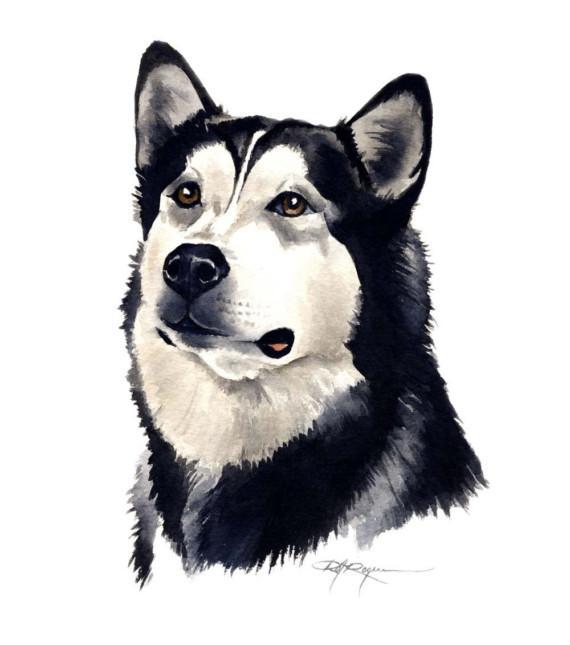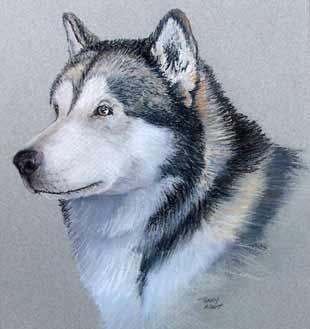The first image is the image on the left, the second image is the image on the right. Assess this claim about the two images: "The right image features a dog with its head and body angled leftward and its tongue hanging out.". Correct or not? Answer yes or no. No. The first image is the image on the left, the second image is the image on the right. Assess this claim about the two images: "In one image the head and paws of an Alaskan Malamute dog are depicted.". Correct or not? Answer yes or no. No. 